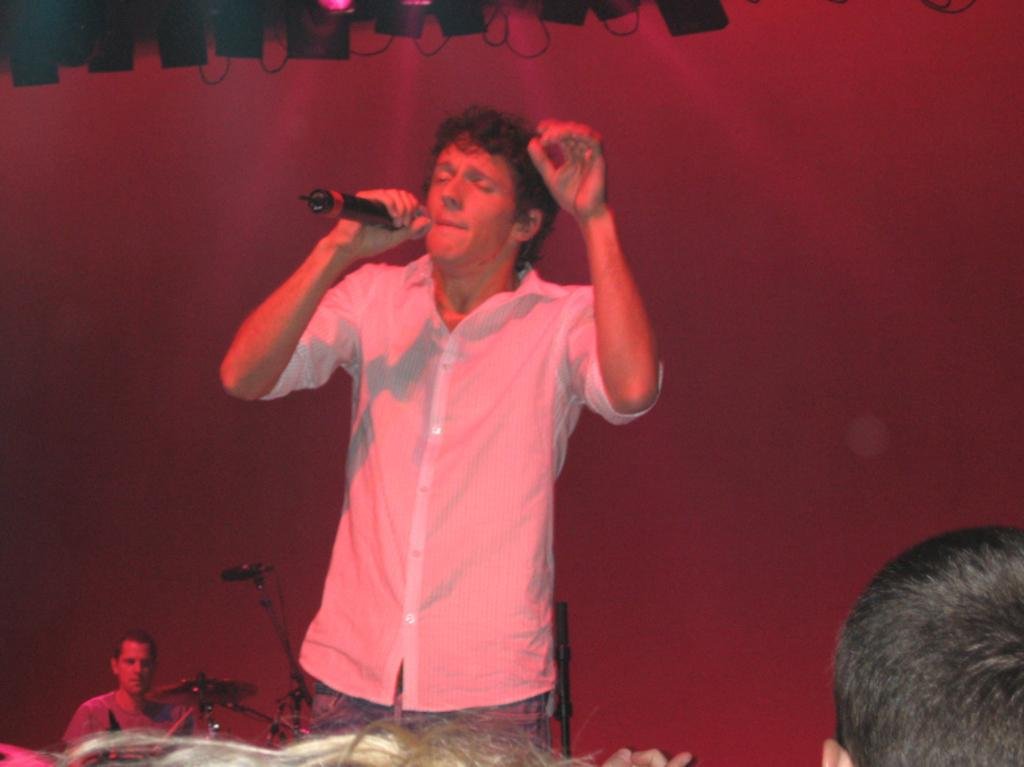What is the person in the image wearing? The person is wearing a white dress. What is the person in the image holding? The person is holding a microphone. Can you describe the person in the background of the image? The person in the background is beating drums. How many apples are on the table in the image? There is no table or apples present in the image. What color are the eggs on the chair in the image? There are no eggs or chairs present in the image. 